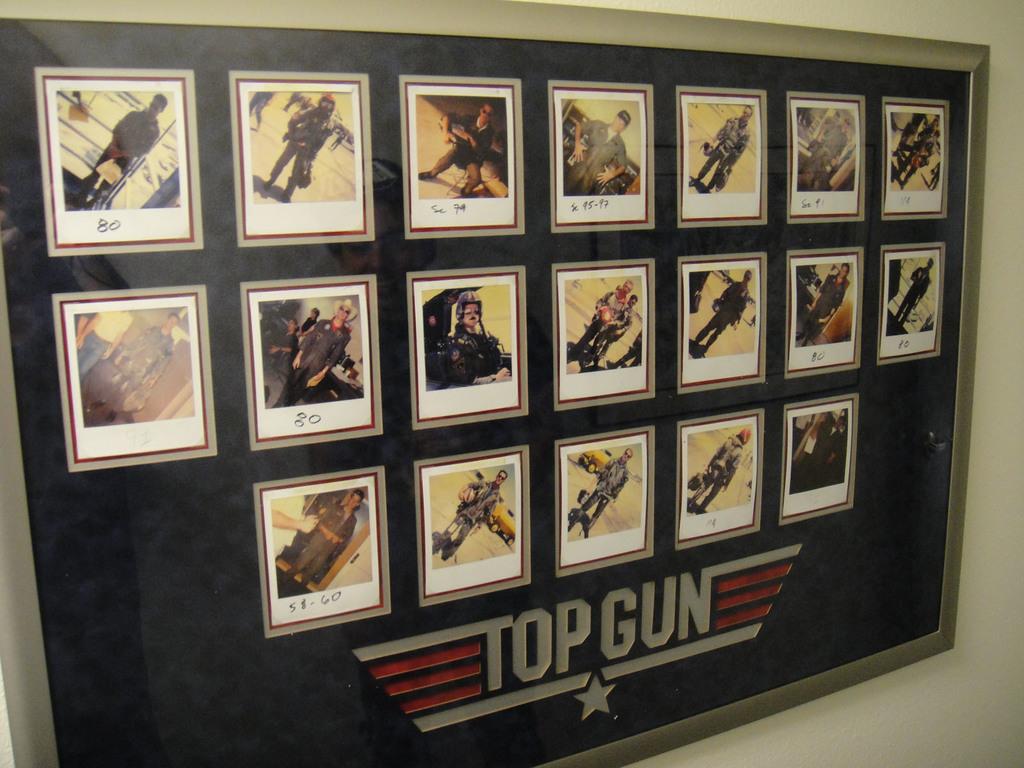What movie is this for?
Provide a succinct answer. Top gun. 